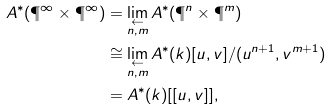<formula> <loc_0><loc_0><loc_500><loc_500>A ^ { * } ( \P ^ { \infty } \times \P ^ { \infty } ) & = \lim _ { \substack { \leftarrow \\ n , m } } A ^ { * } ( \P ^ { n } \times \P ^ { m } ) \\ & \cong \lim _ { \substack { \leftarrow \\ n , m } } A ^ { * } ( k ) [ u , v ] / ( u ^ { n + 1 } , v ^ { m + 1 } ) \\ & = A ^ { * } ( k ) [ [ u , v ] ] ,</formula> 